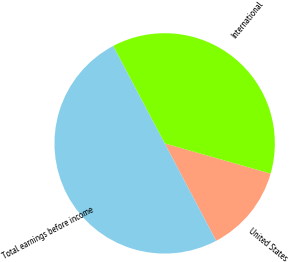Convert chart. <chart><loc_0><loc_0><loc_500><loc_500><pie_chart><fcel>United States<fcel>International<fcel>Total earnings before income<nl><fcel>12.84%<fcel>37.16%<fcel>50.0%<nl></chart> 